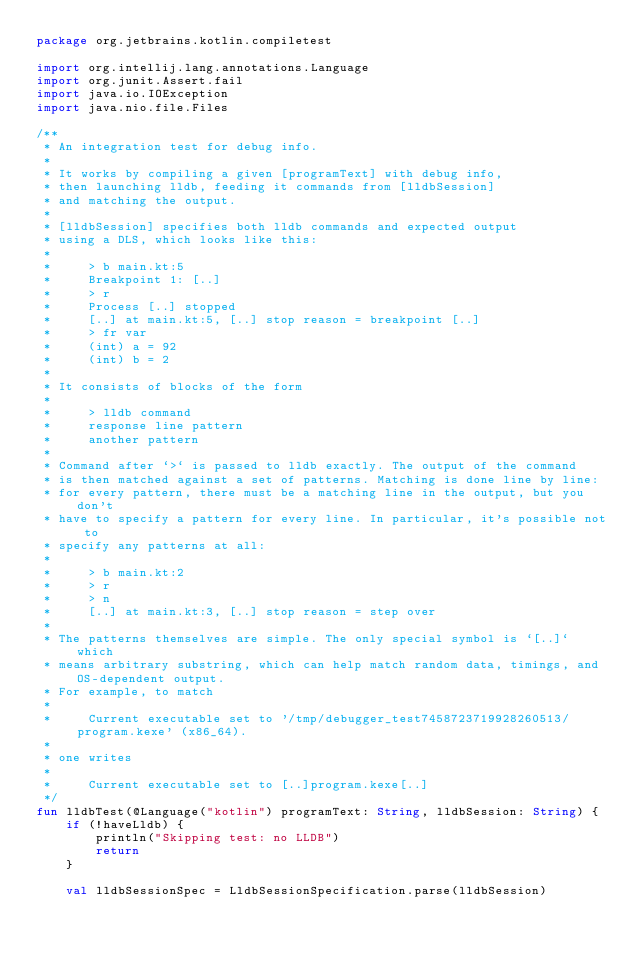<code> <loc_0><loc_0><loc_500><loc_500><_Kotlin_>package org.jetbrains.kotlin.compiletest

import org.intellij.lang.annotations.Language
import org.junit.Assert.fail
import java.io.IOException
import java.nio.file.Files

/**
 * An integration test for debug info.
 *
 * It works by compiling a given [programText] with debug info,
 * then launching lldb, feeding it commands from [lldbSession]
 * and matching the output.
 *
 * [lldbSession] specifies both lldb commands and expected output
 * using a DLS, which looks like this:
 *
 *     > b main.kt:5
 *     Breakpoint 1: [..]
 *     > r
 *     Process [..] stopped
 *     [..] at main.kt:5, [..] stop reason = breakpoint [..]
 *     > fr var
 *     (int) a = 92
 *     (int) b = 2
 *
 * It consists of blocks of the form
 *
 *     > lldb command
 *     response line pattern
 *     another pattern
 *
 * Command after `>` is passed to lldb exactly. The output of the command
 * is then matched against a set of patterns. Matching is done line by line:
 * for every pattern, there must be a matching line in the output, but you don't
 * have to specify a pattern for every line. In particular, it's possible not to
 * specify any patterns at all:
 *
 *     > b main.kt:2
 *     > r
 *     > n
 *     [..] at main.kt:3, [..] stop reason = step over
 *
 * The patterns themselves are simple. The only special symbol is `[..]` which
 * means arbitrary substring, which can help match random data, timings, and OS-dependent output.
 * For example, to match
 *
 *     Current executable set to '/tmp/debugger_test7458723719928260513/program.kexe' (x86_64).
 *
 * one writes
 *
 *     Current executable set to [..]program.kexe[..]
 */
fun lldbTest(@Language("kotlin") programText: String, lldbSession: String) {
    if (!haveLldb) {
        println("Skipping test: no LLDB")
        return
    }

    val lldbSessionSpec = LldbSessionSpecification.parse(lldbSession)
</code> 